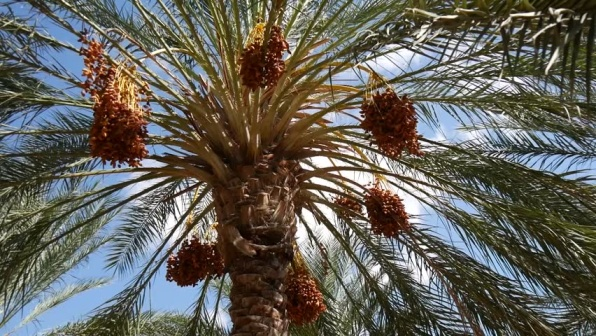What is this photo about'?
 The image captures a vibrant scene of a palm tree thriving under a clear blue sky. The sturdy brown trunk of the tree rises upwards, branching out into lush green leaves that fan out in all directions. Nestled among these leaves are multiple clusters of dates, their orange hue standing out against the greenery. These clusters vary in size and are primarily located towards the top of the tree, hanging like nature's own ornaments. The sunlit backdrop enhances the overall warmth of the scene, highlighting the tree and its bounty of dates. The image does not contain any discernible text or actions. The palm tree, with its multitude of date clusters, is the central focus of the image. 